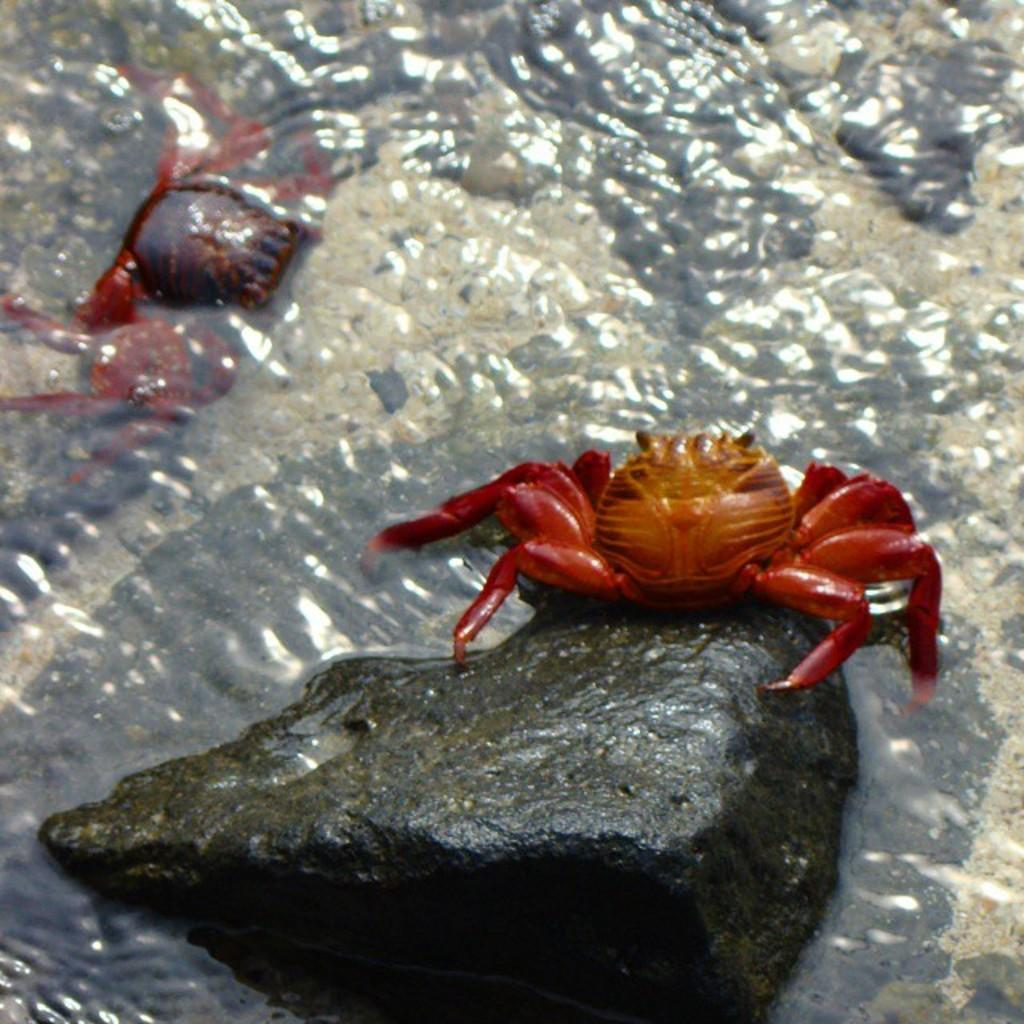What type of animals are in the image? There are crabs in the image. What other object can be seen in the image? There is a stone in the image. Where are the crabs and stone located? The crabs and stone are in the water. What type of train is visible in the image? There is no train present in the image; it features crabs and a stone in the water. What historical event is depicted in the image? There is no historical event depicted in the image; it features crabs and a stone in the water. 